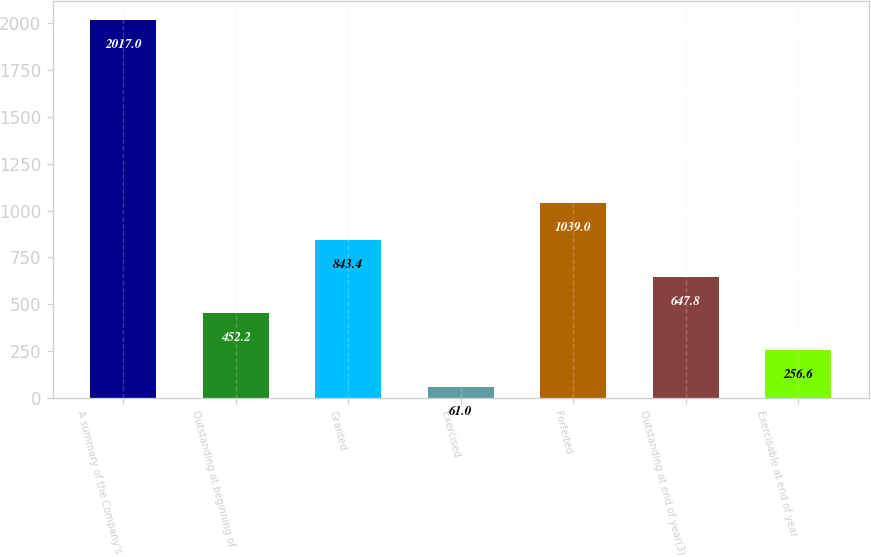<chart> <loc_0><loc_0><loc_500><loc_500><bar_chart><fcel>A summary of the Company's<fcel>Outstanding at beginning of<fcel>Granted<fcel>Exercised<fcel>Forfeited<fcel>Outstanding at end of year(3)<fcel>Exercisable at end of year<nl><fcel>2017<fcel>452.2<fcel>843.4<fcel>61<fcel>1039<fcel>647.8<fcel>256.6<nl></chart> 